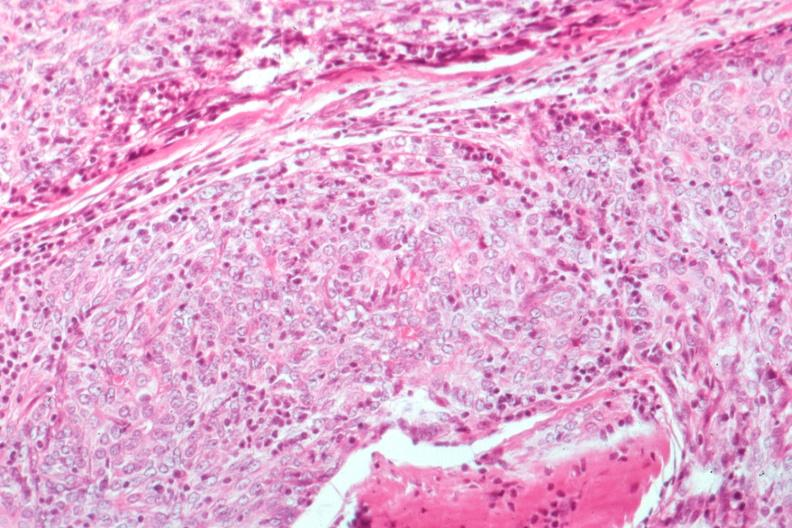what is present?
Answer the question using a single word or phrase. Hematologic 